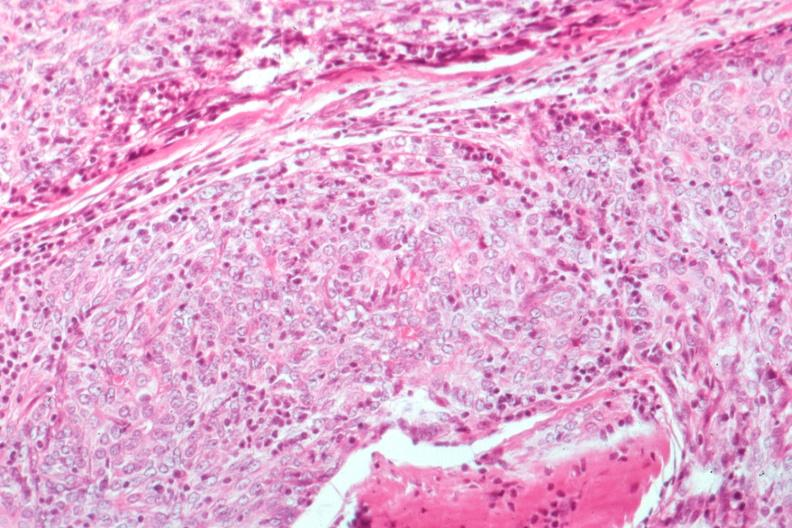what is present?
Answer the question using a single word or phrase. Hematologic 